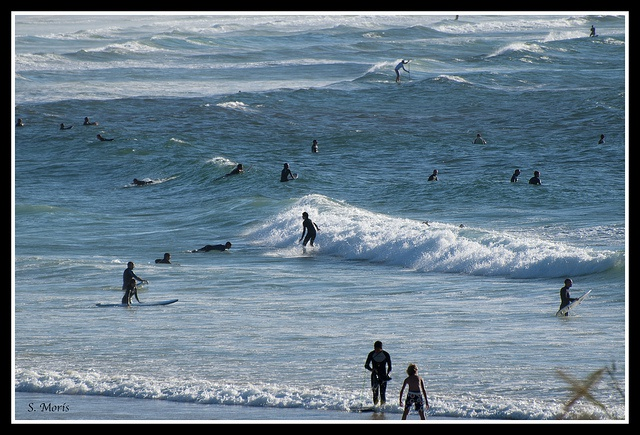Describe the objects in this image and their specific colors. I can see people in black, blue, darkgray, and gray tones, people in black, gray, and navy tones, people in black, darkgray, gray, and navy tones, people in black, gray, darkgray, and lightgray tones, and people in black, gray, navy, and darkgreen tones in this image. 